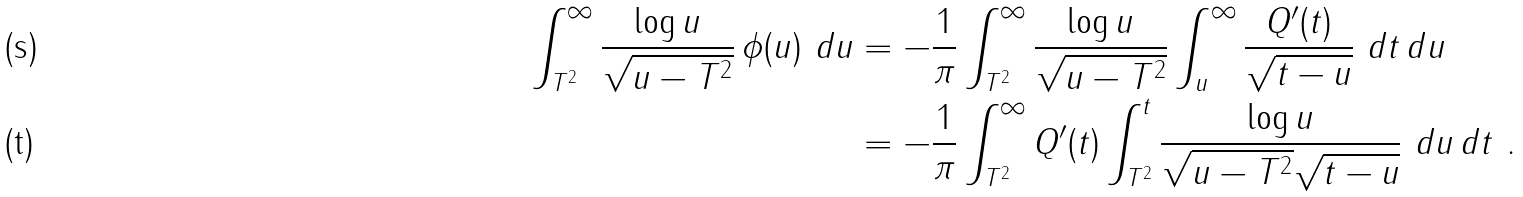<formula> <loc_0><loc_0><loc_500><loc_500>\int _ { T ^ { 2 } } ^ { \infty } \frac { \log u } { \sqrt { u - T ^ { 2 } } } \, \phi ( u ) \ d u & = - \frac { 1 } { \pi } \int _ { T ^ { 2 } } ^ { \infty } \frac { \log u } { \sqrt { u - T ^ { 2 } } } \int _ { u } ^ { \infty } \frac { Q ^ { \prime } ( t ) } { \sqrt { t - u } } \ d t \, d u \\ & = - \frac { 1 } { \pi } \int _ { T ^ { 2 } } ^ { \infty } Q ^ { \prime } ( t ) \int _ { T ^ { 2 } } ^ { t } \frac { \log u } { \sqrt { u - T ^ { 2 } } \sqrt { t - u } } \ d u \, d t \ .</formula> 